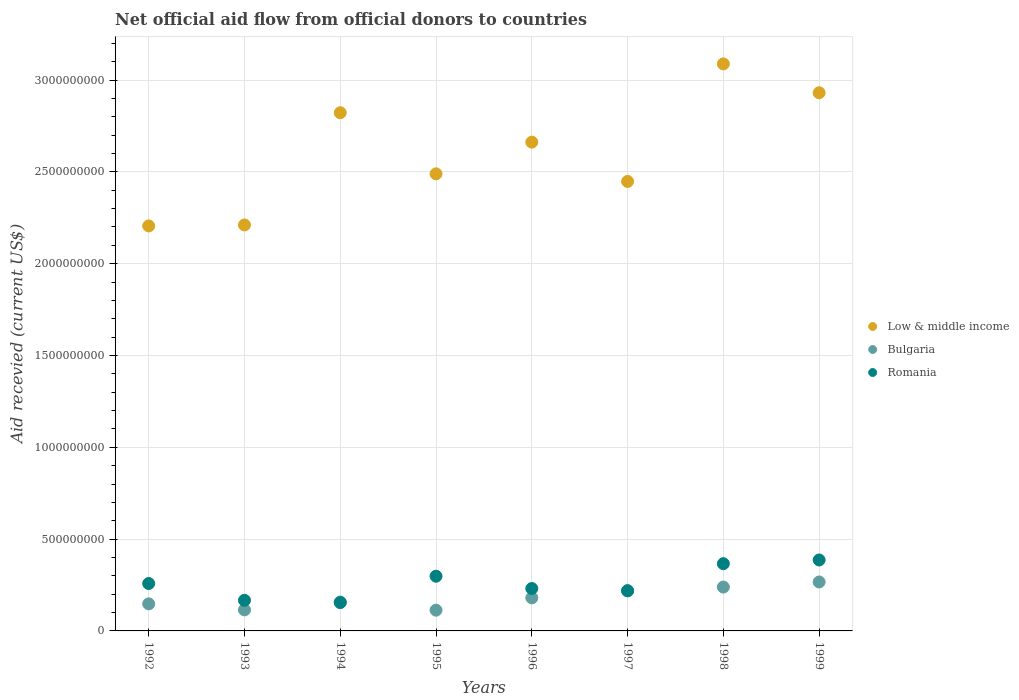What is the total aid received in Low & middle income in 1996?
Keep it short and to the point. 2.66e+09. Across all years, what is the maximum total aid received in Bulgaria?
Ensure brevity in your answer.  2.67e+08. Across all years, what is the minimum total aid received in Romania?
Give a very brief answer. 1.54e+08. In which year was the total aid received in Romania minimum?
Offer a terse response. 1994. What is the total total aid received in Low & middle income in the graph?
Provide a succinct answer. 2.09e+1. What is the difference between the total aid received in Romania in 1992 and that in 1996?
Offer a very short reply. 2.73e+07. What is the difference between the total aid received in Bulgaria in 1997 and the total aid received in Low & middle income in 1995?
Provide a short and direct response. -2.27e+09. What is the average total aid received in Low & middle income per year?
Keep it short and to the point. 2.61e+09. In the year 1994, what is the difference between the total aid received in Low & middle income and total aid received in Bulgaria?
Your response must be concise. 2.66e+09. What is the ratio of the total aid received in Low & middle income in 1995 to that in 1998?
Your response must be concise. 0.81. What is the difference between the highest and the second highest total aid received in Low & middle income?
Your answer should be compact. 1.57e+08. What is the difference between the highest and the lowest total aid received in Bulgaria?
Your answer should be very brief. 1.53e+08. Is the sum of the total aid received in Romania in 1997 and 1998 greater than the maximum total aid received in Low & middle income across all years?
Offer a terse response. No. Is it the case that in every year, the sum of the total aid received in Bulgaria and total aid received in Romania  is greater than the total aid received in Low & middle income?
Your response must be concise. No. Is the total aid received in Low & middle income strictly greater than the total aid received in Bulgaria over the years?
Provide a short and direct response. Yes. Does the graph contain any zero values?
Give a very brief answer. No. Does the graph contain grids?
Make the answer very short. Yes. How many legend labels are there?
Offer a very short reply. 3. What is the title of the graph?
Keep it short and to the point. Net official aid flow from official donors to countries. What is the label or title of the X-axis?
Your answer should be very brief. Years. What is the label or title of the Y-axis?
Your answer should be compact. Aid recevied (current US$). What is the Aid recevied (current US$) in Low & middle income in 1992?
Offer a very short reply. 2.21e+09. What is the Aid recevied (current US$) of Bulgaria in 1992?
Provide a succinct answer. 1.48e+08. What is the Aid recevied (current US$) in Romania in 1992?
Keep it short and to the point. 2.58e+08. What is the Aid recevied (current US$) of Low & middle income in 1993?
Provide a short and direct response. 2.21e+09. What is the Aid recevied (current US$) of Bulgaria in 1993?
Keep it short and to the point. 1.15e+08. What is the Aid recevied (current US$) of Romania in 1993?
Provide a short and direct response. 1.67e+08. What is the Aid recevied (current US$) in Low & middle income in 1994?
Your answer should be very brief. 2.82e+09. What is the Aid recevied (current US$) of Bulgaria in 1994?
Keep it short and to the point. 1.57e+08. What is the Aid recevied (current US$) of Romania in 1994?
Your answer should be compact. 1.54e+08. What is the Aid recevied (current US$) of Low & middle income in 1995?
Offer a very short reply. 2.49e+09. What is the Aid recevied (current US$) of Bulgaria in 1995?
Offer a very short reply. 1.13e+08. What is the Aid recevied (current US$) of Romania in 1995?
Give a very brief answer. 2.98e+08. What is the Aid recevied (current US$) of Low & middle income in 1996?
Provide a succinct answer. 2.66e+09. What is the Aid recevied (current US$) of Bulgaria in 1996?
Your response must be concise. 1.80e+08. What is the Aid recevied (current US$) in Romania in 1996?
Make the answer very short. 2.31e+08. What is the Aid recevied (current US$) of Low & middle income in 1997?
Your answer should be very brief. 2.45e+09. What is the Aid recevied (current US$) in Bulgaria in 1997?
Provide a short and direct response. 2.19e+08. What is the Aid recevied (current US$) of Romania in 1997?
Your response must be concise. 2.18e+08. What is the Aid recevied (current US$) of Low & middle income in 1998?
Provide a short and direct response. 3.09e+09. What is the Aid recevied (current US$) in Bulgaria in 1998?
Your response must be concise. 2.39e+08. What is the Aid recevied (current US$) in Romania in 1998?
Your answer should be very brief. 3.66e+08. What is the Aid recevied (current US$) in Low & middle income in 1999?
Offer a terse response. 2.93e+09. What is the Aid recevied (current US$) in Bulgaria in 1999?
Your answer should be compact. 2.67e+08. What is the Aid recevied (current US$) of Romania in 1999?
Offer a terse response. 3.86e+08. Across all years, what is the maximum Aid recevied (current US$) in Low & middle income?
Provide a short and direct response. 3.09e+09. Across all years, what is the maximum Aid recevied (current US$) of Bulgaria?
Offer a terse response. 2.67e+08. Across all years, what is the maximum Aid recevied (current US$) of Romania?
Your response must be concise. 3.86e+08. Across all years, what is the minimum Aid recevied (current US$) in Low & middle income?
Offer a very short reply. 2.21e+09. Across all years, what is the minimum Aid recevied (current US$) of Bulgaria?
Your answer should be very brief. 1.13e+08. Across all years, what is the minimum Aid recevied (current US$) in Romania?
Offer a very short reply. 1.54e+08. What is the total Aid recevied (current US$) of Low & middle income in the graph?
Your response must be concise. 2.09e+1. What is the total Aid recevied (current US$) in Bulgaria in the graph?
Provide a short and direct response. 1.44e+09. What is the total Aid recevied (current US$) in Romania in the graph?
Keep it short and to the point. 2.08e+09. What is the difference between the Aid recevied (current US$) of Low & middle income in 1992 and that in 1993?
Your answer should be compact. -5.38e+06. What is the difference between the Aid recevied (current US$) in Bulgaria in 1992 and that in 1993?
Your answer should be compact. 3.29e+07. What is the difference between the Aid recevied (current US$) in Romania in 1992 and that in 1993?
Offer a very short reply. 9.15e+07. What is the difference between the Aid recevied (current US$) in Low & middle income in 1992 and that in 1994?
Your answer should be very brief. -6.16e+08. What is the difference between the Aid recevied (current US$) of Bulgaria in 1992 and that in 1994?
Ensure brevity in your answer.  -9.83e+06. What is the difference between the Aid recevied (current US$) in Romania in 1992 and that in 1994?
Make the answer very short. 1.04e+08. What is the difference between the Aid recevied (current US$) of Low & middle income in 1992 and that in 1995?
Give a very brief answer. -2.84e+08. What is the difference between the Aid recevied (current US$) in Bulgaria in 1992 and that in 1995?
Provide a short and direct response. 3.44e+07. What is the difference between the Aid recevied (current US$) of Romania in 1992 and that in 1995?
Your answer should be very brief. -3.97e+07. What is the difference between the Aid recevied (current US$) of Low & middle income in 1992 and that in 1996?
Provide a short and direct response. -4.56e+08. What is the difference between the Aid recevied (current US$) in Bulgaria in 1992 and that in 1996?
Ensure brevity in your answer.  -3.25e+07. What is the difference between the Aid recevied (current US$) in Romania in 1992 and that in 1996?
Your answer should be compact. 2.73e+07. What is the difference between the Aid recevied (current US$) in Low & middle income in 1992 and that in 1997?
Offer a terse response. -2.42e+08. What is the difference between the Aid recevied (current US$) in Bulgaria in 1992 and that in 1997?
Offer a terse response. -7.20e+07. What is the difference between the Aid recevied (current US$) of Romania in 1992 and that in 1997?
Keep it short and to the point. 3.98e+07. What is the difference between the Aid recevied (current US$) of Low & middle income in 1992 and that in 1998?
Keep it short and to the point. -8.82e+08. What is the difference between the Aid recevied (current US$) in Bulgaria in 1992 and that in 1998?
Provide a short and direct response. -9.13e+07. What is the difference between the Aid recevied (current US$) in Romania in 1992 and that in 1998?
Make the answer very short. -1.08e+08. What is the difference between the Aid recevied (current US$) of Low & middle income in 1992 and that in 1999?
Offer a very short reply. -7.25e+08. What is the difference between the Aid recevied (current US$) in Bulgaria in 1992 and that in 1999?
Give a very brief answer. -1.19e+08. What is the difference between the Aid recevied (current US$) in Romania in 1992 and that in 1999?
Your answer should be compact. -1.28e+08. What is the difference between the Aid recevied (current US$) of Low & middle income in 1993 and that in 1994?
Your answer should be very brief. -6.11e+08. What is the difference between the Aid recevied (current US$) of Bulgaria in 1993 and that in 1994?
Provide a short and direct response. -4.27e+07. What is the difference between the Aid recevied (current US$) of Romania in 1993 and that in 1994?
Give a very brief answer. 1.23e+07. What is the difference between the Aid recevied (current US$) of Low & middle income in 1993 and that in 1995?
Provide a short and direct response. -2.78e+08. What is the difference between the Aid recevied (current US$) in Bulgaria in 1993 and that in 1995?
Provide a short and direct response. 1.58e+06. What is the difference between the Aid recevied (current US$) of Romania in 1993 and that in 1995?
Give a very brief answer. -1.31e+08. What is the difference between the Aid recevied (current US$) of Low & middle income in 1993 and that in 1996?
Make the answer very short. -4.51e+08. What is the difference between the Aid recevied (current US$) of Bulgaria in 1993 and that in 1996?
Provide a succinct answer. -6.54e+07. What is the difference between the Aid recevied (current US$) in Romania in 1993 and that in 1996?
Provide a short and direct response. -6.42e+07. What is the difference between the Aid recevied (current US$) of Low & middle income in 1993 and that in 1997?
Your response must be concise. -2.37e+08. What is the difference between the Aid recevied (current US$) in Bulgaria in 1993 and that in 1997?
Provide a short and direct response. -1.05e+08. What is the difference between the Aid recevied (current US$) in Romania in 1993 and that in 1997?
Your answer should be compact. -5.17e+07. What is the difference between the Aid recevied (current US$) of Low & middle income in 1993 and that in 1998?
Your response must be concise. -8.77e+08. What is the difference between the Aid recevied (current US$) of Bulgaria in 1993 and that in 1998?
Provide a short and direct response. -1.24e+08. What is the difference between the Aid recevied (current US$) of Romania in 1993 and that in 1998?
Offer a terse response. -1.99e+08. What is the difference between the Aid recevied (current US$) of Low & middle income in 1993 and that in 1999?
Provide a succinct answer. -7.20e+08. What is the difference between the Aid recevied (current US$) in Bulgaria in 1993 and that in 1999?
Give a very brief answer. -1.52e+08. What is the difference between the Aid recevied (current US$) of Romania in 1993 and that in 1999?
Keep it short and to the point. -2.20e+08. What is the difference between the Aid recevied (current US$) in Low & middle income in 1994 and that in 1995?
Provide a short and direct response. 3.33e+08. What is the difference between the Aid recevied (current US$) in Bulgaria in 1994 and that in 1995?
Offer a very short reply. 4.43e+07. What is the difference between the Aid recevied (current US$) of Romania in 1994 and that in 1995?
Provide a succinct answer. -1.43e+08. What is the difference between the Aid recevied (current US$) in Low & middle income in 1994 and that in 1996?
Offer a terse response. 1.60e+08. What is the difference between the Aid recevied (current US$) in Bulgaria in 1994 and that in 1996?
Your answer should be compact. -2.27e+07. What is the difference between the Aid recevied (current US$) in Romania in 1994 and that in 1996?
Offer a terse response. -7.65e+07. What is the difference between the Aid recevied (current US$) in Low & middle income in 1994 and that in 1997?
Your answer should be very brief. 3.74e+08. What is the difference between the Aid recevied (current US$) in Bulgaria in 1994 and that in 1997?
Your answer should be compact. -6.21e+07. What is the difference between the Aid recevied (current US$) of Romania in 1994 and that in 1997?
Offer a very short reply. -6.40e+07. What is the difference between the Aid recevied (current US$) in Low & middle income in 1994 and that in 1998?
Offer a very short reply. -2.66e+08. What is the difference between the Aid recevied (current US$) of Bulgaria in 1994 and that in 1998?
Your answer should be very brief. -8.15e+07. What is the difference between the Aid recevied (current US$) of Romania in 1994 and that in 1998?
Give a very brief answer. -2.12e+08. What is the difference between the Aid recevied (current US$) of Low & middle income in 1994 and that in 1999?
Keep it short and to the point. -1.09e+08. What is the difference between the Aid recevied (current US$) in Bulgaria in 1994 and that in 1999?
Your response must be concise. -1.09e+08. What is the difference between the Aid recevied (current US$) of Romania in 1994 and that in 1999?
Your answer should be very brief. -2.32e+08. What is the difference between the Aid recevied (current US$) in Low & middle income in 1995 and that in 1996?
Provide a succinct answer. -1.73e+08. What is the difference between the Aid recevied (current US$) in Bulgaria in 1995 and that in 1996?
Keep it short and to the point. -6.70e+07. What is the difference between the Aid recevied (current US$) in Romania in 1995 and that in 1996?
Provide a succinct answer. 6.69e+07. What is the difference between the Aid recevied (current US$) in Low & middle income in 1995 and that in 1997?
Make the answer very short. 4.13e+07. What is the difference between the Aid recevied (current US$) of Bulgaria in 1995 and that in 1997?
Make the answer very short. -1.06e+08. What is the difference between the Aid recevied (current US$) of Romania in 1995 and that in 1997?
Provide a succinct answer. 7.94e+07. What is the difference between the Aid recevied (current US$) in Low & middle income in 1995 and that in 1998?
Your answer should be compact. -5.99e+08. What is the difference between the Aid recevied (current US$) of Bulgaria in 1995 and that in 1998?
Provide a short and direct response. -1.26e+08. What is the difference between the Aid recevied (current US$) of Romania in 1995 and that in 1998?
Your response must be concise. -6.83e+07. What is the difference between the Aid recevied (current US$) in Low & middle income in 1995 and that in 1999?
Provide a short and direct response. -4.42e+08. What is the difference between the Aid recevied (current US$) in Bulgaria in 1995 and that in 1999?
Offer a terse response. -1.53e+08. What is the difference between the Aid recevied (current US$) of Romania in 1995 and that in 1999?
Provide a short and direct response. -8.85e+07. What is the difference between the Aid recevied (current US$) in Low & middle income in 1996 and that in 1997?
Provide a short and direct response. 2.14e+08. What is the difference between the Aid recevied (current US$) in Bulgaria in 1996 and that in 1997?
Your answer should be very brief. -3.94e+07. What is the difference between the Aid recevied (current US$) of Romania in 1996 and that in 1997?
Give a very brief answer. 1.25e+07. What is the difference between the Aid recevied (current US$) of Low & middle income in 1996 and that in 1998?
Your answer should be compact. -4.26e+08. What is the difference between the Aid recevied (current US$) in Bulgaria in 1996 and that in 1998?
Make the answer very short. -5.88e+07. What is the difference between the Aid recevied (current US$) of Romania in 1996 and that in 1998?
Provide a succinct answer. -1.35e+08. What is the difference between the Aid recevied (current US$) in Low & middle income in 1996 and that in 1999?
Offer a terse response. -2.69e+08. What is the difference between the Aid recevied (current US$) in Bulgaria in 1996 and that in 1999?
Provide a short and direct response. -8.65e+07. What is the difference between the Aid recevied (current US$) in Romania in 1996 and that in 1999?
Provide a short and direct response. -1.55e+08. What is the difference between the Aid recevied (current US$) in Low & middle income in 1997 and that in 1998?
Provide a succinct answer. -6.40e+08. What is the difference between the Aid recevied (current US$) in Bulgaria in 1997 and that in 1998?
Your response must be concise. -1.93e+07. What is the difference between the Aid recevied (current US$) in Romania in 1997 and that in 1998?
Provide a succinct answer. -1.48e+08. What is the difference between the Aid recevied (current US$) in Low & middle income in 1997 and that in 1999?
Provide a short and direct response. -4.83e+08. What is the difference between the Aid recevied (current US$) of Bulgaria in 1997 and that in 1999?
Ensure brevity in your answer.  -4.71e+07. What is the difference between the Aid recevied (current US$) in Romania in 1997 and that in 1999?
Offer a very short reply. -1.68e+08. What is the difference between the Aid recevied (current US$) in Low & middle income in 1998 and that in 1999?
Your response must be concise. 1.57e+08. What is the difference between the Aid recevied (current US$) in Bulgaria in 1998 and that in 1999?
Make the answer very short. -2.78e+07. What is the difference between the Aid recevied (current US$) of Romania in 1998 and that in 1999?
Your response must be concise. -2.03e+07. What is the difference between the Aid recevied (current US$) in Low & middle income in 1992 and the Aid recevied (current US$) in Bulgaria in 1993?
Ensure brevity in your answer.  2.09e+09. What is the difference between the Aid recevied (current US$) in Low & middle income in 1992 and the Aid recevied (current US$) in Romania in 1993?
Make the answer very short. 2.04e+09. What is the difference between the Aid recevied (current US$) in Bulgaria in 1992 and the Aid recevied (current US$) in Romania in 1993?
Keep it short and to the point. -1.92e+07. What is the difference between the Aid recevied (current US$) in Low & middle income in 1992 and the Aid recevied (current US$) in Bulgaria in 1994?
Provide a short and direct response. 2.05e+09. What is the difference between the Aid recevied (current US$) in Low & middle income in 1992 and the Aid recevied (current US$) in Romania in 1994?
Your answer should be very brief. 2.05e+09. What is the difference between the Aid recevied (current US$) in Bulgaria in 1992 and the Aid recevied (current US$) in Romania in 1994?
Your answer should be very brief. -6.88e+06. What is the difference between the Aid recevied (current US$) in Low & middle income in 1992 and the Aid recevied (current US$) in Bulgaria in 1995?
Make the answer very short. 2.09e+09. What is the difference between the Aid recevied (current US$) in Low & middle income in 1992 and the Aid recevied (current US$) in Romania in 1995?
Keep it short and to the point. 1.91e+09. What is the difference between the Aid recevied (current US$) of Bulgaria in 1992 and the Aid recevied (current US$) of Romania in 1995?
Provide a succinct answer. -1.50e+08. What is the difference between the Aid recevied (current US$) in Low & middle income in 1992 and the Aid recevied (current US$) in Bulgaria in 1996?
Offer a very short reply. 2.03e+09. What is the difference between the Aid recevied (current US$) of Low & middle income in 1992 and the Aid recevied (current US$) of Romania in 1996?
Give a very brief answer. 1.97e+09. What is the difference between the Aid recevied (current US$) of Bulgaria in 1992 and the Aid recevied (current US$) of Romania in 1996?
Your response must be concise. -8.34e+07. What is the difference between the Aid recevied (current US$) in Low & middle income in 1992 and the Aid recevied (current US$) in Bulgaria in 1997?
Provide a short and direct response. 1.99e+09. What is the difference between the Aid recevied (current US$) of Low & middle income in 1992 and the Aid recevied (current US$) of Romania in 1997?
Offer a very short reply. 1.99e+09. What is the difference between the Aid recevied (current US$) in Bulgaria in 1992 and the Aid recevied (current US$) in Romania in 1997?
Give a very brief answer. -7.09e+07. What is the difference between the Aid recevied (current US$) in Low & middle income in 1992 and the Aid recevied (current US$) in Bulgaria in 1998?
Give a very brief answer. 1.97e+09. What is the difference between the Aid recevied (current US$) in Low & middle income in 1992 and the Aid recevied (current US$) in Romania in 1998?
Offer a terse response. 1.84e+09. What is the difference between the Aid recevied (current US$) in Bulgaria in 1992 and the Aid recevied (current US$) in Romania in 1998?
Offer a very short reply. -2.19e+08. What is the difference between the Aid recevied (current US$) of Low & middle income in 1992 and the Aid recevied (current US$) of Bulgaria in 1999?
Make the answer very short. 1.94e+09. What is the difference between the Aid recevied (current US$) in Low & middle income in 1992 and the Aid recevied (current US$) in Romania in 1999?
Offer a terse response. 1.82e+09. What is the difference between the Aid recevied (current US$) of Bulgaria in 1992 and the Aid recevied (current US$) of Romania in 1999?
Your answer should be compact. -2.39e+08. What is the difference between the Aid recevied (current US$) of Low & middle income in 1993 and the Aid recevied (current US$) of Bulgaria in 1994?
Offer a very short reply. 2.05e+09. What is the difference between the Aid recevied (current US$) in Low & middle income in 1993 and the Aid recevied (current US$) in Romania in 1994?
Ensure brevity in your answer.  2.06e+09. What is the difference between the Aid recevied (current US$) in Bulgaria in 1993 and the Aid recevied (current US$) in Romania in 1994?
Offer a very short reply. -3.97e+07. What is the difference between the Aid recevied (current US$) of Low & middle income in 1993 and the Aid recevied (current US$) of Bulgaria in 1995?
Make the answer very short. 2.10e+09. What is the difference between the Aid recevied (current US$) in Low & middle income in 1993 and the Aid recevied (current US$) in Romania in 1995?
Your response must be concise. 1.91e+09. What is the difference between the Aid recevied (current US$) in Bulgaria in 1993 and the Aid recevied (current US$) in Romania in 1995?
Your response must be concise. -1.83e+08. What is the difference between the Aid recevied (current US$) of Low & middle income in 1993 and the Aid recevied (current US$) of Bulgaria in 1996?
Give a very brief answer. 2.03e+09. What is the difference between the Aid recevied (current US$) in Low & middle income in 1993 and the Aid recevied (current US$) in Romania in 1996?
Offer a very short reply. 1.98e+09. What is the difference between the Aid recevied (current US$) in Bulgaria in 1993 and the Aid recevied (current US$) in Romania in 1996?
Ensure brevity in your answer.  -1.16e+08. What is the difference between the Aid recevied (current US$) of Low & middle income in 1993 and the Aid recevied (current US$) of Bulgaria in 1997?
Give a very brief answer. 1.99e+09. What is the difference between the Aid recevied (current US$) in Low & middle income in 1993 and the Aid recevied (current US$) in Romania in 1997?
Provide a succinct answer. 1.99e+09. What is the difference between the Aid recevied (current US$) in Bulgaria in 1993 and the Aid recevied (current US$) in Romania in 1997?
Provide a short and direct response. -1.04e+08. What is the difference between the Aid recevied (current US$) of Low & middle income in 1993 and the Aid recevied (current US$) of Bulgaria in 1998?
Provide a short and direct response. 1.97e+09. What is the difference between the Aid recevied (current US$) of Low & middle income in 1993 and the Aid recevied (current US$) of Romania in 1998?
Keep it short and to the point. 1.84e+09. What is the difference between the Aid recevied (current US$) of Bulgaria in 1993 and the Aid recevied (current US$) of Romania in 1998?
Ensure brevity in your answer.  -2.51e+08. What is the difference between the Aid recevied (current US$) in Low & middle income in 1993 and the Aid recevied (current US$) in Bulgaria in 1999?
Your answer should be very brief. 1.94e+09. What is the difference between the Aid recevied (current US$) of Low & middle income in 1993 and the Aid recevied (current US$) of Romania in 1999?
Give a very brief answer. 1.82e+09. What is the difference between the Aid recevied (current US$) in Bulgaria in 1993 and the Aid recevied (current US$) in Romania in 1999?
Your answer should be compact. -2.72e+08. What is the difference between the Aid recevied (current US$) of Low & middle income in 1994 and the Aid recevied (current US$) of Bulgaria in 1995?
Ensure brevity in your answer.  2.71e+09. What is the difference between the Aid recevied (current US$) of Low & middle income in 1994 and the Aid recevied (current US$) of Romania in 1995?
Offer a very short reply. 2.52e+09. What is the difference between the Aid recevied (current US$) of Bulgaria in 1994 and the Aid recevied (current US$) of Romania in 1995?
Your response must be concise. -1.41e+08. What is the difference between the Aid recevied (current US$) of Low & middle income in 1994 and the Aid recevied (current US$) of Bulgaria in 1996?
Give a very brief answer. 2.64e+09. What is the difference between the Aid recevied (current US$) in Low & middle income in 1994 and the Aid recevied (current US$) in Romania in 1996?
Give a very brief answer. 2.59e+09. What is the difference between the Aid recevied (current US$) of Bulgaria in 1994 and the Aid recevied (current US$) of Romania in 1996?
Offer a very short reply. -7.36e+07. What is the difference between the Aid recevied (current US$) in Low & middle income in 1994 and the Aid recevied (current US$) in Bulgaria in 1997?
Provide a short and direct response. 2.60e+09. What is the difference between the Aid recevied (current US$) of Low & middle income in 1994 and the Aid recevied (current US$) of Romania in 1997?
Keep it short and to the point. 2.60e+09. What is the difference between the Aid recevied (current US$) of Bulgaria in 1994 and the Aid recevied (current US$) of Romania in 1997?
Your response must be concise. -6.11e+07. What is the difference between the Aid recevied (current US$) in Low & middle income in 1994 and the Aid recevied (current US$) in Bulgaria in 1998?
Give a very brief answer. 2.58e+09. What is the difference between the Aid recevied (current US$) in Low & middle income in 1994 and the Aid recevied (current US$) in Romania in 1998?
Keep it short and to the point. 2.46e+09. What is the difference between the Aid recevied (current US$) in Bulgaria in 1994 and the Aid recevied (current US$) in Romania in 1998?
Ensure brevity in your answer.  -2.09e+08. What is the difference between the Aid recevied (current US$) of Low & middle income in 1994 and the Aid recevied (current US$) of Bulgaria in 1999?
Provide a short and direct response. 2.56e+09. What is the difference between the Aid recevied (current US$) of Low & middle income in 1994 and the Aid recevied (current US$) of Romania in 1999?
Offer a terse response. 2.44e+09. What is the difference between the Aid recevied (current US$) of Bulgaria in 1994 and the Aid recevied (current US$) of Romania in 1999?
Offer a very short reply. -2.29e+08. What is the difference between the Aid recevied (current US$) of Low & middle income in 1995 and the Aid recevied (current US$) of Bulgaria in 1996?
Offer a terse response. 2.31e+09. What is the difference between the Aid recevied (current US$) of Low & middle income in 1995 and the Aid recevied (current US$) of Romania in 1996?
Your answer should be compact. 2.26e+09. What is the difference between the Aid recevied (current US$) of Bulgaria in 1995 and the Aid recevied (current US$) of Romania in 1996?
Ensure brevity in your answer.  -1.18e+08. What is the difference between the Aid recevied (current US$) in Low & middle income in 1995 and the Aid recevied (current US$) in Bulgaria in 1997?
Your answer should be very brief. 2.27e+09. What is the difference between the Aid recevied (current US$) in Low & middle income in 1995 and the Aid recevied (current US$) in Romania in 1997?
Your answer should be very brief. 2.27e+09. What is the difference between the Aid recevied (current US$) in Bulgaria in 1995 and the Aid recevied (current US$) in Romania in 1997?
Ensure brevity in your answer.  -1.05e+08. What is the difference between the Aid recevied (current US$) in Low & middle income in 1995 and the Aid recevied (current US$) in Bulgaria in 1998?
Provide a short and direct response. 2.25e+09. What is the difference between the Aid recevied (current US$) of Low & middle income in 1995 and the Aid recevied (current US$) of Romania in 1998?
Offer a terse response. 2.12e+09. What is the difference between the Aid recevied (current US$) of Bulgaria in 1995 and the Aid recevied (current US$) of Romania in 1998?
Keep it short and to the point. -2.53e+08. What is the difference between the Aid recevied (current US$) in Low & middle income in 1995 and the Aid recevied (current US$) in Bulgaria in 1999?
Ensure brevity in your answer.  2.22e+09. What is the difference between the Aid recevied (current US$) of Low & middle income in 1995 and the Aid recevied (current US$) of Romania in 1999?
Your response must be concise. 2.10e+09. What is the difference between the Aid recevied (current US$) in Bulgaria in 1995 and the Aid recevied (current US$) in Romania in 1999?
Keep it short and to the point. -2.73e+08. What is the difference between the Aid recevied (current US$) of Low & middle income in 1996 and the Aid recevied (current US$) of Bulgaria in 1997?
Your answer should be very brief. 2.44e+09. What is the difference between the Aid recevied (current US$) of Low & middle income in 1996 and the Aid recevied (current US$) of Romania in 1997?
Your answer should be compact. 2.44e+09. What is the difference between the Aid recevied (current US$) of Bulgaria in 1996 and the Aid recevied (current US$) of Romania in 1997?
Your response must be concise. -3.84e+07. What is the difference between the Aid recevied (current US$) of Low & middle income in 1996 and the Aid recevied (current US$) of Bulgaria in 1998?
Your answer should be very brief. 2.42e+09. What is the difference between the Aid recevied (current US$) of Low & middle income in 1996 and the Aid recevied (current US$) of Romania in 1998?
Provide a succinct answer. 2.30e+09. What is the difference between the Aid recevied (current US$) of Bulgaria in 1996 and the Aid recevied (current US$) of Romania in 1998?
Offer a terse response. -1.86e+08. What is the difference between the Aid recevied (current US$) of Low & middle income in 1996 and the Aid recevied (current US$) of Bulgaria in 1999?
Offer a terse response. 2.40e+09. What is the difference between the Aid recevied (current US$) of Low & middle income in 1996 and the Aid recevied (current US$) of Romania in 1999?
Give a very brief answer. 2.28e+09. What is the difference between the Aid recevied (current US$) of Bulgaria in 1996 and the Aid recevied (current US$) of Romania in 1999?
Offer a terse response. -2.06e+08. What is the difference between the Aid recevied (current US$) in Low & middle income in 1997 and the Aid recevied (current US$) in Bulgaria in 1998?
Make the answer very short. 2.21e+09. What is the difference between the Aid recevied (current US$) in Low & middle income in 1997 and the Aid recevied (current US$) in Romania in 1998?
Offer a very short reply. 2.08e+09. What is the difference between the Aid recevied (current US$) of Bulgaria in 1997 and the Aid recevied (current US$) of Romania in 1998?
Your answer should be compact. -1.47e+08. What is the difference between the Aid recevied (current US$) of Low & middle income in 1997 and the Aid recevied (current US$) of Bulgaria in 1999?
Keep it short and to the point. 2.18e+09. What is the difference between the Aid recevied (current US$) in Low & middle income in 1997 and the Aid recevied (current US$) in Romania in 1999?
Your response must be concise. 2.06e+09. What is the difference between the Aid recevied (current US$) in Bulgaria in 1997 and the Aid recevied (current US$) in Romania in 1999?
Offer a very short reply. -1.67e+08. What is the difference between the Aid recevied (current US$) in Low & middle income in 1998 and the Aid recevied (current US$) in Bulgaria in 1999?
Your answer should be compact. 2.82e+09. What is the difference between the Aid recevied (current US$) of Low & middle income in 1998 and the Aid recevied (current US$) of Romania in 1999?
Your response must be concise. 2.70e+09. What is the difference between the Aid recevied (current US$) in Bulgaria in 1998 and the Aid recevied (current US$) in Romania in 1999?
Provide a short and direct response. -1.48e+08. What is the average Aid recevied (current US$) of Low & middle income per year?
Your answer should be very brief. 2.61e+09. What is the average Aid recevied (current US$) of Bulgaria per year?
Your answer should be compact. 1.80e+08. What is the average Aid recevied (current US$) in Romania per year?
Provide a short and direct response. 2.60e+08. In the year 1992, what is the difference between the Aid recevied (current US$) of Low & middle income and Aid recevied (current US$) of Bulgaria?
Make the answer very short. 2.06e+09. In the year 1992, what is the difference between the Aid recevied (current US$) of Low & middle income and Aid recevied (current US$) of Romania?
Offer a very short reply. 1.95e+09. In the year 1992, what is the difference between the Aid recevied (current US$) in Bulgaria and Aid recevied (current US$) in Romania?
Offer a very short reply. -1.11e+08. In the year 1993, what is the difference between the Aid recevied (current US$) in Low & middle income and Aid recevied (current US$) in Bulgaria?
Provide a succinct answer. 2.10e+09. In the year 1993, what is the difference between the Aid recevied (current US$) of Low & middle income and Aid recevied (current US$) of Romania?
Keep it short and to the point. 2.04e+09. In the year 1993, what is the difference between the Aid recevied (current US$) in Bulgaria and Aid recevied (current US$) in Romania?
Give a very brief answer. -5.20e+07. In the year 1994, what is the difference between the Aid recevied (current US$) in Low & middle income and Aid recevied (current US$) in Bulgaria?
Provide a succinct answer. 2.66e+09. In the year 1994, what is the difference between the Aid recevied (current US$) of Low & middle income and Aid recevied (current US$) of Romania?
Keep it short and to the point. 2.67e+09. In the year 1994, what is the difference between the Aid recevied (current US$) of Bulgaria and Aid recevied (current US$) of Romania?
Offer a terse response. 2.95e+06. In the year 1995, what is the difference between the Aid recevied (current US$) of Low & middle income and Aid recevied (current US$) of Bulgaria?
Offer a terse response. 2.38e+09. In the year 1995, what is the difference between the Aid recevied (current US$) in Low & middle income and Aid recevied (current US$) in Romania?
Provide a short and direct response. 2.19e+09. In the year 1995, what is the difference between the Aid recevied (current US$) in Bulgaria and Aid recevied (current US$) in Romania?
Your answer should be compact. -1.85e+08. In the year 1996, what is the difference between the Aid recevied (current US$) in Low & middle income and Aid recevied (current US$) in Bulgaria?
Make the answer very short. 2.48e+09. In the year 1996, what is the difference between the Aid recevied (current US$) of Low & middle income and Aid recevied (current US$) of Romania?
Provide a short and direct response. 2.43e+09. In the year 1996, what is the difference between the Aid recevied (current US$) in Bulgaria and Aid recevied (current US$) in Romania?
Keep it short and to the point. -5.09e+07. In the year 1997, what is the difference between the Aid recevied (current US$) in Low & middle income and Aid recevied (current US$) in Bulgaria?
Your answer should be compact. 2.23e+09. In the year 1997, what is the difference between the Aid recevied (current US$) of Low & middle income and Aid recevied (current US$) of Romania?
Your response must be concise. 2.23e+09. In the year 1997, what is the difference between the Aid recevied (current US$) of Bulgaria and Aid recevied (current US$) of Romania?
Provide a short and direct response. 1.05e+06. In the year 1998, what is the difference between the Aid recevied (current US$) of Low & middle income and Aid recevied (current US$) of Bulgaria?
Make the answer very short. 2.85e+09. In the year 1998, what is the difference between the Aid recevied (current US$) in Low & middle income and Aid recevied (current US$) in Romania?
Provide a short and direct response. 2.72e+09. In the year 1998, what is the difference between the Aid recevied (current US$) in Bulgaria and Aid recevied (current US$) in Romania?
Your response must be concise. -1.27e+08. In the year 1999, what is the difference between the Aid recevied (current US$) in Low & middle income and Aid recevied (current US$) in Bulgaria?
Provide a succinct answer. 2.66e+09. In the year 1999, what is the difference between the Aid recevied (current US$) in Low & middle income and Aid recevied (current US$) in Romania?
Offer a terse response. 2.54e+09. In the year 1999, what is the difference between the Aid recevied (current US$) in Bulgaria and Aid recevied (current US$) in Romania?
Your response must be concise. -1.20e+08. What is the ratio of the Aid recevied (current US$) in Low & middle income in 1992 to that in 1993?
Give a very brief answer. 1. What is the ratio of the Aid recevied (current US$) of Bulgaria in 1992 to that in 1993?
Keep it short and to the point. 1.29. What is the ratio of the Aid recevied (current US$) of Romania in 1992 to that in 1993?
Your response must be concise. 1.55. What is the ratio of the Aid recevied (current US$) of Low & middle income in 1992 to that in 1994?
Your answer should be compact. 0.78. What is the ratio of the Aid recevied (current US$) in Romania in 1992 to that in 1994?
Provide a succinct answer. 1.67. What is the ratio of the Aid recevied (current US$) in Low & middle income in 1992 to that in 1995?
Your answer should be very brief. 0.89. What is the ratio of the Aid recevied (current US$) in Bulgaria in 1992 to that in 1995?
Keep it short and to the point. 1.3. What is the ratio of the Aid recevied (current US$) of Romania in 1992 to that in 1995?
Provide a succinct answer. 0.87. What is the ratio of the Aid recevied (current US$) in Low & middle income in 1992 to that in 1996?
Provide a succinct answer. 0.83. What is the ratio of the Aid recevied (current US$) of Bulgaria in 1992 to that in 1996?
Your answer should be compact. 0.82. What is the ratio of the Aid recevied (current US$) in Romania in 1992 to that in 1996?
Keep it short and to the point. 1.12. What is the ratio of the Aid recevied (current US$) of Low & middle income in 1992 to that in 1997?
Make the answer very short. 0.9. What is the ratio of the Aid recevied (current US$) of Bulgaria in 1992 to that in 1997?
Ensure brevity in your answer.  0.67. What is the ratio of the Aid recevied (current US$) of Romania in 1992 to that in 1997?
Your response must be concise. 1.18. What is the ratio of the Aid recevied (current US$) in Low & middle income in 1992 to that in 1998?
Offer a terse response. 0.71. What is the ratio of the Aid recevied (current US$) of Bulgaria in 1992 to that in 1998?
Give a very brief answer. 0.62. What is the ratio of the Aid recevied (current US$) in Romania in 1992 to that in 1998?
Your answer should be compact. 0.71. What is the ratio of the Aid recevied (current US$) of Low & middle income in 1992 to that in 1999?
Your answer should be compact. 0.75. What is the ratio of the Aid recevied (current US$) of Bulgaria in 1992 to that in 1999?
Offer a very short reply. 0.55. What is the ratio of the Aid recevied (current US$) of Romania in 1992 to that in 1999?
Make the answer very short. 0.67. What is the ratio of the Aid recevied (current US$) in Low & middle income in 1993 to that in 1994?
Provide a short and direct response. 0.78. What is the ratio of the Aid recevied (current US$) of Bulgaria in 1993 to that in 1994?
Your response must be concise. 0.73. What is the ratio of the Aid recevied (current US$) of Romania in 1993 to that in 1994?
Your answer should be compact. 1.08. What is the ratio of the Aid recevied (current US$) in Low & middle income in 1993 to that in 1995?
Ensure brevity in your answer.  0.89. What is the ratio of the Aid recevied (current US$) in Romania in 1993 to that in 1995?
Your answer should be very brief. 0.56. What is the ratio of the Aid recevied (current US$) in Low & middle income in 1993 to that in 1996?
Offer a terse response. 0.83. What is the ratio of the Aid recevied (current US$) in Bulgaria in 1993 to that in 1996?
Provide a short and direct response. 0.64. What is the ratio of the Aid recevied (current US$) in Romania in 1993 to that in 1996?
Provide a short and direct response. 0.72. What is the ratio of the Aid recevied (current US$) in Low & middle income in 1993 to that in 1997?
Give a very brief answer. 0.9. What is the ratio of the Aid recevied (current US$) of Bulgaria in 1993 to that in 1997?
Keep it short and to the point. 0.52. What is the ratio of the Aid recevied (current US$) in Romania in 1993 to that in 1997?
Your response must be concise. 0.76. What is the ratio of the Aid recevied (current US$) of Low & middle income in 1993 to that in 1998?
Give a very brief answer. 0.72. What is the ratio of the Aid recevied (current US$) of Bulgaria in 1993 to that in 1998?
Keep it short and to the point. 0.48. What is the ratio of the Aid recevied (current US$) in Romania in 1993 to that in 1998?
Make the answer very short. 0.46. What is the ratio of the Aid recevied (current US$) in Low & middle income in 1993 to that in 1999?
Give a very brief answer. 0.75. What is the ratio of the Aid recevied (current US$) of Bulgaria in 1993 to that in 1999?
Ensure brevity in your answer.  0.43. What is the ratio of the Aid recevied (current US$) of Romania in 1993 to that in 1999?
Offer a very short reply. 0.43. What is the ratio of the Aid recevied (current US$) of Low & middle income in 1994 to that in 1995?
Provide a succinct answer. 1.13. What is the ratio of the Aid recevied (current US$) of Bulgaria in 1994 to that in 1995?
Provide a short and direct response. 1.39. What is the ratio of the Aid recevied (current US$) in Romania in 1994 to that in 1995?
Keep it short and to the point. 0.52. What is the ratio of the Aid recevied (current US$) in Low & middle income in 1994 to that in 1996?
Offer a very short reply. 1.06. What is the ratio of the Aid recevied (current US$) in Bulgaria in 1994 to that in 1996?
Your answer should be very brief. 0.87. What is the ratio of the Aid recevied (current US$) in Romania in 1994 to that in 1996?
Offer a very short reply. 0.67. What is the ratio of the Aid recevied (current US$) in Low & middle income in 1994 to that in 1997?
Ensure brevity in your answer.  1.15. What is the ratio of the Aid recevied (current US$) of Bulgaria in 1994 to that in 1997?
Your answer should be compact. 0.72. What is the ratio of the Aid recevied (current US$) in Romania in 1994 to that in 1997?
Ensure brevity in your answer.  0.71. What is the ratio of the Aid recevied (current US$) of Low & middle income in 1994 to that in 1998?
Give a very brief answer. 0.91. What is the ratio of the Aid recevied (current US$) of Bulgaria in 1994 to that in 1998?
Provide a short and direct response. 0.66. What is the ratio of the Aid recevied (current US$) in Romania in 1994 to that in 1998?
Make the answer very short. 0.42. What is the ratio of the Aid recevied (current US$) in Low & middle income in 1994 to that in 1999?
Provide a short and direct response. 0.96. What is the ratio of the Aid recevied (current US$) of Bulgaria in 1994 to that in 1999?
Provide a succinct answer. 0.59. What is the ratio of the Aid recevied (current US$) of Romania in 1994 to that in 1999?
Provide a succinct answer. 0.4. What is the ratio of the Aid recevied (current US$) in Low & middle income in 1995 to that in 1996?
Give a very brief answer. 0.94. What is the ratio of the Aid recevied (current US$) of Bulgaria in 1995 to that in 1996?
Make the answer very short. 0.63. What is the ratio of the Aid recevied (current US$) of Romania in 1995 to that in 1996?
Give a very brief answer. 1.29. What is the ratio of the Aid recevied (current US$) of Low & middle income in 1995 to that in 1997?
Offer a terse response. 1.02. What is the ratio of the Aid recevied (current US$) of Bulgaria in 1995 to that in 1997?
Offer a very short reply. 0.52. What is the ratio of the Aid recevied (current US$) in Romania in 1995 to that in 1997?
Your response must be concise. 1.36. What is the ratio of the Aid recevied (current US$) of Low & middle income in 1995 to that in 1998?
Keep it short and to the point. 0.81. What is the ratio of the Aid recevied (current US$) of Bulgaria in 1995 to that in 1998?
Keep it short and to the point. 0.47. What is the ratio of the Aid recevied (current US$) in Romania in 1995 to that in 1998?
Make the answer very short. 0.81. What is the ratio of the Aid recevied (current US$) of Low & middle income in 1995 to that in 1999?
Provide a short and direct response. 0.85. What is the ratio of the Aid recevied (current US$) of Bulgaria in 1995 to that in 1999?
Your response must be concise. 0.42. What is the ratio of the Aid recevied (current US$) in Romania in 1995 to that in 1999?
Provide a succinct answer. 0.77. What is the ratio of the Aid recevied (current US$) of Low & middle income in 1996 to that in 1997?
Offer a terse response. 1.09. What is the ratio of the Aid recevied (current US$) of Bulgaria in 1996 to that in 1997?
Your answer should be compact. 0.82. What is the ratio of the Aid recevied (current US$) of Romania in 1996 to that in 1997?
Your response must be concise. 1.06. What is the ratio of the Aid recevied (current US$) of Low & middle income in 1996 to that in 1998?
Make the answer very short. 0.86. What is the ratio of the Aid recevied (current US$) of Bulgaria in 1996 to that in 1998?
Keep it short and to the point. 0.75. What is the ratio of the Aid recevied (current US$) in Romania in 1996 to that in 1998?
Keep it short and to the point. 0.63. What is the ratio of the Aid recevied (current US$) in Low & middle income in 1996 to that in 1999?
Give a very brief answer. 0.91. What is the ratio of the Aid recevied (current US$) of Bulgaria in 1996 to that in 1999?
Your answer should be very brief. 0.68. What is the ratio of the Aid recevied (current US$) of Romania in 1996 to that in 1999?
Make the answer very short. 0.6. What is the ratio of the Aid recevied (current US$) of Low & middle income in 1997 to that in 1998?
Ensure brevity in your answer.  0.79. What is the ratio of the Aid recevied (current US$) in Bulgaria in 1997 to that in 1998?
Your response must be concise. 0.92. What is the ratio of the Aid recevied (current US$) of Romania in 1997 to that in 1998?
Your response must be concise. 0.6. What is the ratio of the Aid recevied (current US$) of Low & middle income in 1997 to that in 1999?
Offer a very short reply. 0.84. What is the ratio of the Aid recevied (current US$) in Bulgaria in 1997 to that in 1999?
Your response must be concise. 0.82. What is the ratio of the Aid recevied (current US$) of Romania in 1997 to that in 1999?
Make the answer very short. 0.57. What is the ratio of the Aid recevied (current US$) of Low & middle income in 1998 to that in 1999?
Ensure brevity in your answer.  1.05. What is the ratio of the Aid recevied (current US$) of Bulgaria in 1998 to that in 1999?
Your response must be concise. 0.9. What is the ratio of the Aid recevied (current US$) in Romania in 1998 to that in 1999?
Your answer should be compact. 0.95. What is the difference between the highest and the second highest Aid recevied (current US$) in Low & middle income?
Ensure brevity in your answer.  1.57e+08. What is the difference between the highest and the second highest Aid recevied (current US$) of Bulgaria?
Keep it short and to the point. 2.78e+07. What is the difference between the highest and the second highest Aid recevied (current US$) of Romania?
Your answer should be compact. 2.03e+07. What is the difference between the highest and the lowest Aid recevied (current US$) of Low & middle income?
Give a very brief answer. 8.82e+08. What is the difference between the highest and the lowest Aid recevied (current US$) in Bulgaria?
Ensure brevity in your answer.  1.53e+08. What is the difference between the highest and the lowest Aid recevied (current US$) in Romania?
Make the answer very short. 2.32e+08. 